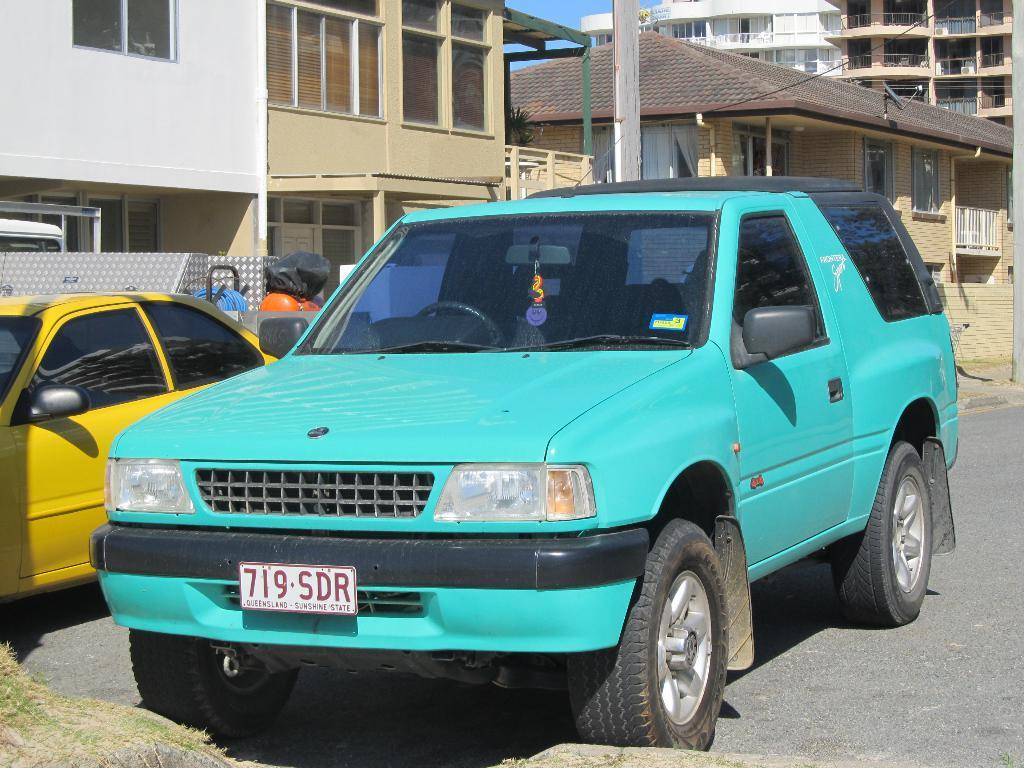Provide a one-sentence caption for the provided image. Parking space behind a building with a teal SUV from Queensland. 